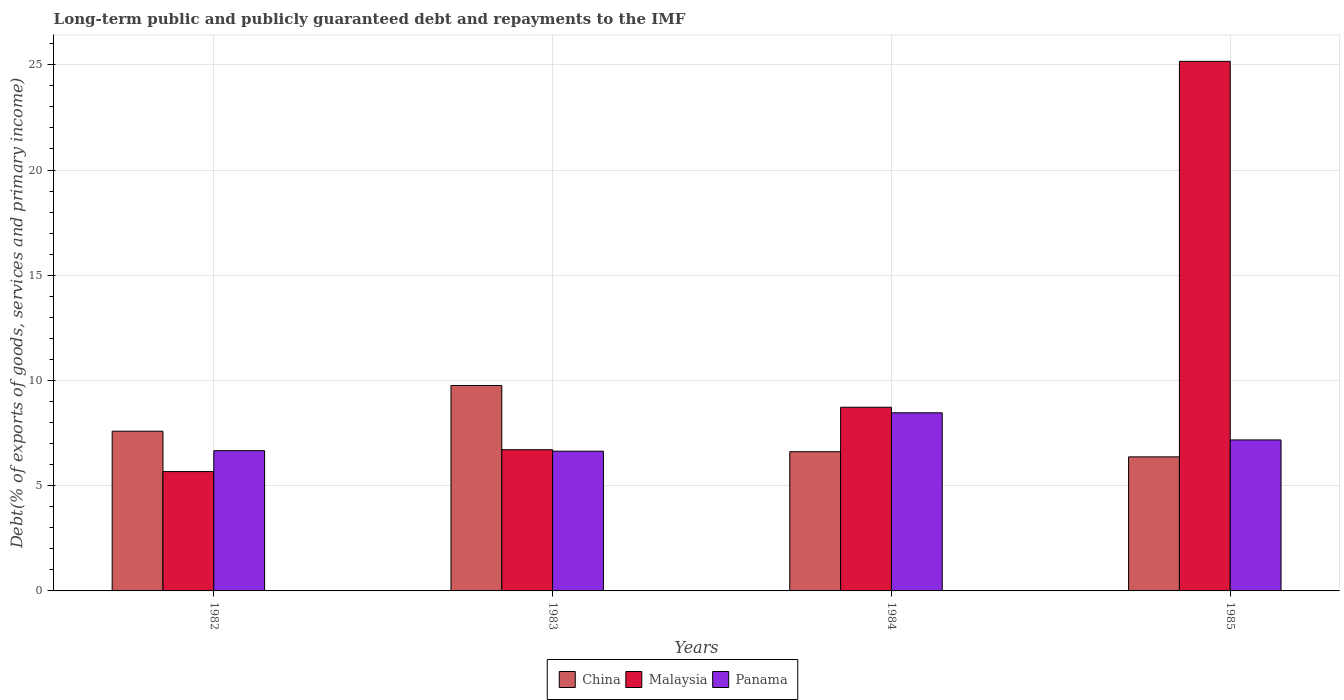How many different coloured bars are there?
Ensure brevity in your answer.  3. Are the number of bars per tick equal to the number of legend labels?
Offer a very short reply. Yes. Are the number of bars on each tick of the X-axis equal?
Offer a very short reply. Yes. What is the label of the 4th group of bars from the left?
Your response must be concise. 1985. What is the debt and repayments in China in 1984?
Your answer should be compact. 6.61. Across all years, what is the maximum debt and repayments in Panama?
Ensure brevity in your answer.  8.46. Across all years, what is the minimum debt and repayments in China?
Offer a very short reply. 6.37. What is the total debt and repayments in Malaysia in the graph?
Give a very brief answer. 46.27. What is the difference between the debt and repayments in Malaysia in 1983 and that in 1984?
Ensure brevity in your answer.  -2.02. What is the difference between the debt and repayments in Panama in 1985 and the debt and repayments in China in 1984?
Make the answer very short. 0.56. What is the average debt and repayments in Panama per year?
Your response must be concise. 7.24. In the year 1984, what is the difference between the debt and repayments in China and debt and repayments in Panama?
Offer a very short reply. -1.85. What is the ratio of the debt and repayments in Panama in 1983 to that in 1985?
Make the answer very short. 0.93. Is the debt and repayments in Panama in 1984 less than that in 1985?
Provide a short and direct response. No. What is the difference between the highest and the second highest debt and repayments in China?
Your response must be concise. 2.17. What is the difference between the highest and the lowest debt and repayments in Malaysia?
Ensure brevity in your answer.  19.49. In how many years, is the debt and repayments in China greater than the average debt and repayments in China taken over all years?
Your answer should be compact. 2. What does the 3rd bar from the left in 1984 represents?
Offer a very short reply. Panama. What does the 2nd bar from the right in 1983 represents?
Offer a very short reply. Malaysia. How many bars are there?
Make the answer very short. 12. Are the values on the major ticks of Y-axis written in scientific E-notation?
Provide a succinct answer. No. How many legend labels are there?
Ensure brevity in your answer.  3. What is the title of the graph?
Ensure brevity in your answer.  Long-term public and publicly guaranteed debt and repayments to the IMF. Does "Singapore" appear as one of the legend labels in the graph?
Provide a short and direct response. No. What is the label or title of the X-axis?
Provide a succinct answer. Years. What is the label or title of the Y-axis?
Provide a succinct answer. Debt(% of exports of goods, services and primary income). What is the Debt(% of exports of goods, services and primary income) of China in 1982?
Your response must be concise. 7.59. What is the Debt(% of exports of goods, services and primary income) in Malaysia in 1982?
Offer a very short reply. 5.67. What is the Debt(% of exports of goods, services and primary income) in Panama in 1982?
Make the answer very short. 6.66. What is the Debt(% of exports of goods, services and primary income) of China in 1983?
Your answer should be compact. 9.76. What is the Debt(% of exports of goods, services and primary income) in Malaysia in 1983?
Offer a very short reply. 6.71. What is the Debt(% of exports of goods, services and primary income) in Panama in 1983?
Your answer should be compact. 6.64. What is the Debt(% of exports of goods, services and primary income) in China in 1984?
Give a very brief answer. 6.61. What is the Debt(% of exports of goods, services and primary income) in Malaysia in 1984?
Ensure brevity in your answer.  8.73. What is the Debt(% of exports of goods, services and primary income) of Panama in 1984?
Provide a short and direct response. 8.46. What is the Debt(% of exports of goods, services and primary income) of China in 1985?
Offer a very short reply. 6.37. What is the Debt(% of exports of goods, services and primary income) of Malaysia in 1985?
Provide a succinct answer. 25.16. What is the Debt(% of exports of goods, services and primary income) in Panama in 1985?
Keep it short and to the point. 7.17. Across all years, what is the maximum Debt(% of exports of goods, services and primary income) in China?
Offer a very short reply. 9.76. Across all years, what is the maximum Debt(% of exports of goods, services and primary income) of Malaysia?
Ensure brevity in your answer.  25.16. Across all years, what is the maximum Debt(% of exports of goods, services and primary income) of Panama?
Provide a short and direct response. 8.46. Across all years, what is the minimum Debt(% of exports of goods, services and primary income) of China?
Provide a short and direct response. 6.37. Across all years, what is the minimum Debt(% of exports of goods, services and primary income) in Malaysia?
Your answer should be very brief. 5.67. Across all years, what is the minimum Debt(% of exports of goods, services and primary income) in Panama?
Make the answer very short. 6.64. What is the total Debt(% of exports of goods, services and primary income) of China in the graph?
Your answer should be very brief. 30.34. What is the total Debt(% of exports of goods, services and primary income) in Malaysia in the graph?
Keep it short and to the point. 46.27. What is the total Debt(% of exports of goods, services and primary income) of Panama in the graph?
Keep it short and to the point. 28.94. What is the difference between the Debt(% of exports of goods, services and primary income) of China in 1982 and that in 1983?
Make the answer very short. -2.17. What is the difference between the Debt(% of exports of goods, services and primary income) of Malaysia in 1982 and that in 1983?
Your answer should be compact. -1.04. What is the difference between the Debt(% of exports of goods, services and primary income) of Panama in 1982 and that in 1983?
Offer a terse response. 0.02. What is the difference between the Debt(% of exports of goods, services and primary income) in China in 1982 and that in 1984?
Your response must be concise. 0.97. What is the difference between the Debt(% of exports of goods, services and primary income) of Malaysia in 1982 and that in 1984?
Give a very brief answer. -3.06. What is the difference between the Debt(% of exports of goods, services and primary income) of Panama in 1982 and that in 1984?
Provide a short and direct response. -1.8. What is the difference between the Debt(% of exports of goods, services and primary income) of China in 1982 and that in 1985?
Provide a short and direct response. 1.22. What is the difference between the Debt(% of exports of goods, services and primary income) of Malaysia in 1982 and that in 1985?
Keep it short and to the point. -19.49. What is the difference between the Debt(% of exports of goods, services and primary income) of Panama in 1982 and that in 1985?
Offer a very short reply. -0.51. What is the difference between the Debt(% of exports of goods, services and primary income) of China in 1983 and that in 1984?
Your response must be concise. 3.15. What is the difference between the Debt(% of exports of goods, services and primary income) of Malaysia in 1983 and that in 1984?
Offer a terse response. -2.02. What is the difference between the Debt(% of exports of goods, services and primary income) of Panama in 1983 and that in 1984?
Keep it short and to the point. -1.82. What is the difference between the Debt(% of exports of goods, services and primary income) of China in 1983 and that in 1985?
Your response must be concise. 3.39. What is the difference between the Debt(% of exports of goods, services and primary income) in Malaysia in 1983 and that in 1985?
Provide a succinct answer. -18.45. What is the difference between the Debt(% of exports of goods, services and primary income) in Panama in 1983 and that in 1985?
Provide a succinct answer. -0.53. What is the difference between the Debt(% of exports of goods, services and primary income) of China in 1984 and that in 1985?
Offer a very short reply. 0.24. What is the difference between the Debt(% of exports of goods, services and primary income) in Malaysia in 1984 and that in 1985?
Provide a succinct answer. -16.44. What is the difference between the Debt(% of exports of goods, services and primary income) of Panama in 1984 and that in 1985?
Your answer should be very brief. 1.29. What is the difference between the Debt(% of exports of goods, services and primary income) in China in 1982 and the Debt(% of exports of goods, services and primary income) in Malaysia in 1983?
Offer a very short reply. 0.88. What is the difference between the Debt(% of exports of goods, services and primary income) in China in 1982 and the Debt(% of exports of goods, services and primary income) in Panama in 1983?
Offer a very short reply. 0.95. What is the difference between the Debt(% of exports of goods, services and primary income) in Malaysia in 1982 and the Debt(% of exports of goods, services and primary income) in Panama in 1983?
Make the answer very short. -0.97. What is the difference between the Debt(% of exports of goods, services and primary income) of China in 1982 and the Debt(% of exports of goods, services and primary income) of Malaysia in 1984?
Provide a short and direct response. -1.14. What is the difference between the Debt(% of exports of goods, services and primary income) in China in 1982 and the Debt(% of exports of goods, services and primary income) in Panama in 1984?
Ensure brevity in your answer.  -0.87. What is the difference between the Debt(% of exports of goods, services and primary income) of Malaysia in 1982 and the Debt(% of exports of goods, services and primary income) of Panama in 1984?
Your response must be concise. -2.79. What is the difference between the Debt(% of exports of goods, services and primary income) in China in 1982 and the Debt(% of exports of goods, services and primary income) in Malaysia in 1985?
Give a very brief answer. -17.57. What is the difference between the Debt(% of exports of goods, services and primary income) in China in 1982 and the Debt(% of exports of goods, services and primary income) in Panama in 1985?
Provide a succinct answer. 0.42. What is the difference between the Debt(% of exports of goods, services and primary income) of Malaysia in 1982 and the Debt(% of exports of goods, services and primary income) of Panama in 1985?
Offer a very short reply. -1.5. What is the difference between the Debt(% of exports of goods, services and primary income) of China in 1983 and the Debt(% of exports of goods, services and primary income) of Malaysia in 1984?
Make the answer very short. 1.03. What is the difference between the Debt(% of exports of goods, services and primary income) of China in 1983 and the Debt(% of exports of goods, services and primary income) of Panama in 1984?
Keep it short and to the point. 1.3. What is the difference between the Debt(% of exports of goods, services and primary income) in Malaysia in 1983 and the Debt(% of exports of goods, services and primary income) in Panama in 1984?
Provide a short and direct response. -1.75. What is the difference between the Debt(% of exports of goods, services and primary income) in China in 1983 and the Debt(% of exports of goods, services and primary income) in Malaysia in 1985?
Give a very brief answer. -15.4. What is the difference between the Debt(% of exports of goods, services and primary income) in China in 1983 and the Debt(% of exports of goods, services and primary income) in Panama in 1985?
Your answer should be very brief. 2.59. What is the difference between the Debt(% of exports of goods, services and primary income) in Malaysia in 1983 and the Debt(% of exports of goods, services and primary income) in Panama in 1985?
Provide a short and direct response. -0.46. What is the difference between the Debt(% of exports of goods, services and primary income) in China in 1984 and the Debt(% of exports of goods, services and primary income) in Malaysia in 1985?
Ensure brevity in your answer.  -18.55. What is the difference between the Debt(% of exports of goods, services and primary income) in China in 1984 and the Debt(% of exports of goods, services and primary income) in Panama in 1985?
Offer a very short reply. -0.56. What is the difference between the Debt(% of exports of goods, services and primary income) in Malaysia in 1984 and the Debt(% of exports of goods, services and primary income) in Panama in 1985?
Your response must be concise. 1.55. What is the average Debt(% of exports of goods, services and primary income) in China per year?
Provide a succinct answer. 7.58. What is the average Debt(% of exports of goods, services and primary income) of Malaysia per year?
Offer a very short reply. 11.57. What is the average Debt(% of exports of goods, services and primary income) in Panama per year?
Your response must be concise. 7.24. In the year 1982, what is the difference between the Debt(% of exports of goods, services and primary income) of China and Debt(% of exports of goods, services and primary income) of Malaysia?
Offer a very short reply. 1.92. In the year 1982, what is the difference between the Debt(% of exports of goods, services and primary income) of China and Debt(% of exports of goods, services and primary income) of Panama?
Your response must be concise. 0.93. In the year 1982, what is the difference between the Debt(% of exports of goods, services and primary income) in Malaysia and Debt(% of exports of goods, services and primary income) in Panama?
Your answer should be very brief. -0.99. In the year 1983, what is the difference between the Debt(% of exports of goods, services and primary income) of China and Debt(% of exports of goods, services and primary income) of Malaysia?
Provide a succinct answer. 3.05. In the year 1983, what is the difference between the Debt(% of exports of goods, services and primary income) of China and Debt(% of exports of goods, services and primary income) of Panama?
Keep it short and to the point. 3.12. In the year 1983, what is the difference between the Debt(% of exports of goods, services and primary income) in Malaysia and Debt(% of exports of goods, services and primary income) in Panama?
Your answer should be very brief. 0.07. In the year 1984, what is the difference between the Debt(% of exports of goods, services and primary income) of China and Debt(% of exports of goods, services and primary income) of Malaysia?
Provide a succinct answer. -2.11. In the year 1984, what is the difference between the Debt(% of exports of goods, services and primary income) in China and Debt(% of exports of goods, services and primary income) in Panama?
Your response must be concise. -1.85. In the year 1984, what is the difference between the Debt(% of exports of goods, services and primary income) in Malaysia and Debt(% of exports of goods, services and primary income) in Panama?
Give a very brief answer. 0.26. In the year 1985, what is the difference between the Debt(% of exports of goods, services and primary income) of China and Debt(% of exports of goods, services and primary income) of Malaysia?
Provide a succinct answer. -18.79. In the year 1985, what is the difference between the Debt(% of exports of goods, services and primary income) of China and Debt(% of exports of goods, services and primary income) of Panama?
Make the answer very short. -0.8. In the year 1985, what is the difference between the Debt(% of exports of goods, services and primary income) of Malaysia and Debt(% of exports of goods, services and primary income) of Panama?
Give a very brief answer. 17.99. What is the ratio of the Debt(% of exports of goods, services and primary income) of China in 1982 to that in 1983?
Give a very brief answer. 0.78. What is the ratio of the Debt(% of exports of goods, services and primary income) in Malaysia in 1982 to that in 1983?
Offer a very short reply. 0.85. What is the ratio of the Debt(% of exports of goods, services and primary income) in Panama in 1982 to that in 1983?
Offer a very short reply. 1. What is the ratio of the Debt(% of exports of goods, services and primary income) in China in 1982 to that in 1984?
Offer a terse response. 1.15. What is the ratio of the Debt(% of exports of goods, services and primary income) in Malaysia in 1982 to that in 1984?
Make the answer very short. 0.65. What is the ratio of the Debt(% of exports of goods, services and primary income) of Panama in 1982 to that in 1984?
Ensure brevity in your answer.  0.79. What is the ratio of the Debt(% of exports of goods, services and primary income) in China in 1982 to that in 1985?
Provide a short and direct response. 1.19. What is the ratio of the Debt(% of exports of goods, services and primary income) of Malaysia in 1982 to that in 1985?
Offer a very short reply. 0.23. What is the ratio of the Debt(% of exports of goods, services and primary income) of Panama in 1982 to that in 1985?
Keep it short and to the point. 0.93. What is the ratio of the Debt(% of exports of goods, services and primary income) of China in 1983 to that in 1984?
Offer a terse response. 1.48. What is the ratio of the Debt(% of exports of goods, services and primary income) in Malaysia in 1983 to that in 1984?
Offer a terse response. 0.77. What is the ratio of the Debt(% of exports of goods, services and primary income) of Panama in 1983 to that in 1984?
Your response must be concise. 0.78. What is the ratio of the Debt(% of exports of goods, services and primary income) of China in 1983 to that in 1985?
Keep it short and to the point. 1.53. What is the ratio of the Debt(% of exports of goods, services and primary income) in Malaysia in 1983 to that in 1985?
Keep it short and to the point. 0.27. What is the ratio of the Debt(% of exports of goods, services and primary income) in Panama in 1983 to that in 1985?
Your response must be concise. 0.93. What is the ratio of the Debt(% of exports of goods, services and primary income) in China in 1984 to that in 1985?
Provide a succinct answer. 1.04. What is the ratio of the Debt(% of exports of goods, services and primary income) of Malaysia in 1984 to that in 1985?
Offer a very short reply. 0.35. What is the ratio of the Debt(% of exports of goods, services and primary income) of Panama in 1984 to that in 1985?
Offer a terse response. 1.18. What is the difference between the highest and the second highest Debt(% of exports of goods, services and primary income) of China?
Provide a succinct answer. 2.17. What is the difference between the highest and the second highest Debt(% of exports of goods, services and primary income) of Malaysia?
Your response must be concise. 16.44. What is the difference between the highest and the second highest Debt(% of exports of goods, services and primary income) of Panama?
Keep it short and to the point. 1.29. What is the difference between the highest and the lowest Debt(% of exports of goods, services and primary income) in China?
Provide a short and direct response. 3.39. What is the difference between the highest and the lowest Debt(% of exports of goods, services and primary income) of Malaysia?
Provide a short and direct response. 19.49. What is the difference between the highest and the lowest Debt(% of exports of goods, services and primary income) in Panama?
Give a very brief answer. 1.82. 